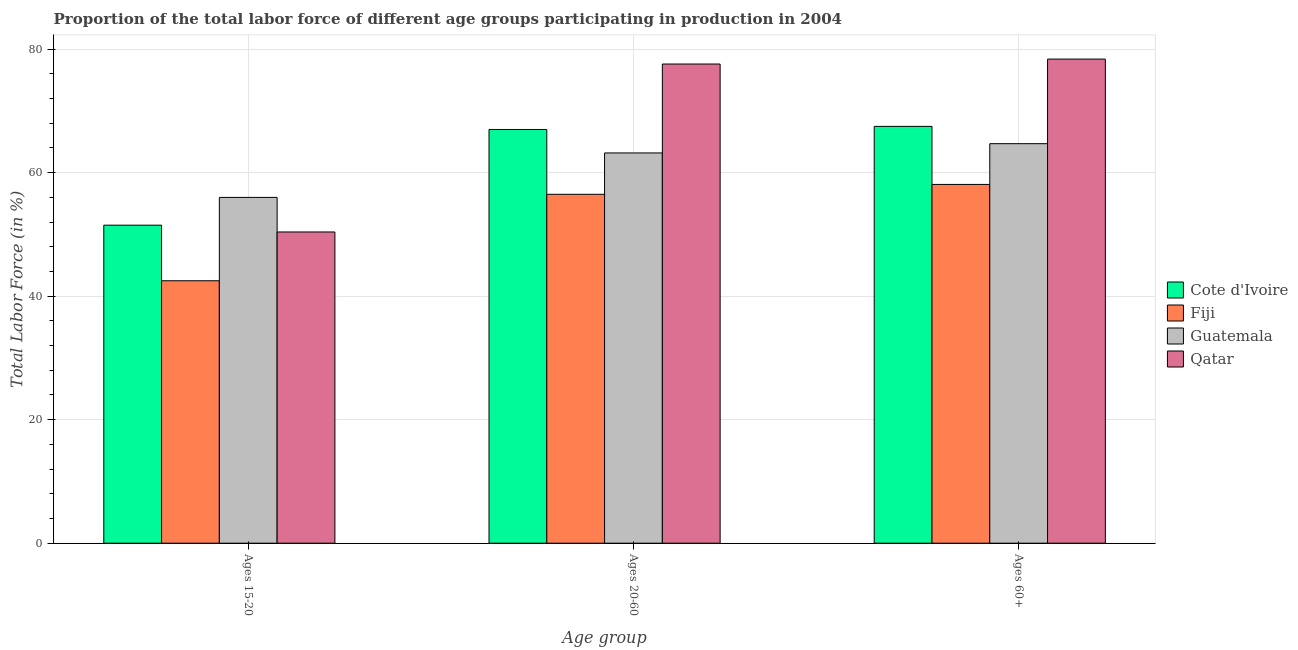How many different coloured bars are there?
Your answer should be compact. 4. How many groups of bars are there?
Give a very brief answer. 3. Are the number of bars per tick equal to the number of legend labels?
Your response must be concise. Yes. Are the number of bars on each tick of the X-axis equal?
Offer a terse response. Yes. What is the label of the 1st group of bars from the left?
Your response must be concise. Ages 15-20. What is the percentage of labor force within the age group 15-20 in Qatar?
Give a very brief answer. 50.4. Across all countries, what is the maximum percentage of labor force within the age group 20-60?
Provide a succinct answer. 77.6. Across all countries, what is the minimum percentage of labor force within the age group 20-60?
Offer a very short reply. 56.5. In which country was the percentage of labor force within the age group 20-60 maximum?
Your answer should be compact. Qatar. In which country was the percentage of labor force above age 60 minimum?
Your response must be concise. Fiji. What is the total percentage of labor force within the age group 20-60 in the graph?
Keep it short and to the point. 264.3. What is the difference between the percentage of labor force within the age group 20-60 in Guatemala and that in Fiji?
Your answer should be compact. 6.7. What is the difference between the percentage of labor force within the age group 20-60 in Guatemala and the percentage of labor force above age 60 in Fiji?
Keep it short and to the point. 5.1. What is the average percentage of labor force within the age group 15-20 per country?
Make the answer very short. 50.1. What is the difference between the percentage of labor force within the age group 15-20 and percentage of labor force within the age group 20-60 in Guatemala?
Offer a terse response. -7.2. In how many countries, is the percentage of labor force within the age group 20-60 greater than 24 %?
Ensure brevity in your answer.  4. What is the ratio of the percentage of labor force above age 60 in Guatemala to that in Qatar?
Provide a succinct answer. 0.83. Is the percentage of labor force within the age group 15-20 in Cote d'Ivoire less than that in Guatemala?
Your response must be concise. Yes. What is the difference between the highest and the second highest percentage of labor force above age 60?
Offer a very short reply. 10.9. What is the difference between the highest and the lowest percentage of labor force within the age group 20-60?
Offer a very short reply. 21.1. In how many countries, is the percentage of labor force above age 60 greater than the average percentage of labor force above age 60 taken over all countries?
Offer a terse response. 2. What does the 4th bar from the left in Ages 15-20 represents?
Your answer should be very brief. Qatar. What does the 2nd bar from the right in Ages 20-60 represents?
Make the answer very short. Guatemala. Is it the case that in every country, the sum of the percentage of labor force within the age group 15-20 and percentage of labor force within the age group 20-60 is greater than the percentage of labor force above age 60?
Give a very brief answer. Yes. How many bars are there?
Make the answer very short. 12. Are all the bars in the graph horizontal?
Ensure brevity in your answer.  No. Does the graph contain grids?
Offer a terse response. Yes. Where does the legend appear in the graph?
Your answer should be compact. Center right. How many legend labels are there?
Keep it short and to the point. 4. What is the title of the graph?
Make the answer very short. Proportion of the total labor force of different age groups participating in production in 2004. What is the label or title of the X-axis?
Offer a terse response. Age group. What is the label or title of the Y-axis?
Provide a short and direct response. Total Labor Force (in %). What is the Total Labor Force (in %) of Cote d'Ivoire in Ages 15-20?
Your response must be concise. 51.5. What is the Total Labor Force (in %) in Fiji in Ages 15-20?
Your response must be concise. 42.5. What is the Total Labor Force (in %) of Qatar in Ages 15-20?
Your answer should be compact. 50.4. What is the Total Labor Force (in %) of Fiji in Ages 20-60?
Your response must be concise. 56.5. What is the Total Labor Force (in %) in Guatemala in Ages 20-60?
Make the answer very short. 63.2. What is the Total Labor Force (in %) in Qatar in Ages 20-60?
Keep it short and to the point. 77.6. What is the Total Labor Force (in %) in Cote d'Ivoire in Ages 60+?
Your answer should be very brief. 67.5. What is the Total Labor Force (in %) of Fiji in Ages 60+?
Give a very brief answer. 58.1. What is the Total Labor Force (in %) in Guatemala in Ages 60+?
Ensure brevity in your answer.  64.7. What is the Total Labor Force (in %) of Qatar in Ages 60+?
Provide a succinct answer. 78.4. Across all Age group, what is the maximum Total Labor Force (in %) in Cote d'Ivoire?
Make the answer very short. 67.5. Across all Age group, what is the maximum Total Labor Force (in %) in Fiji?
Provide a succinct answer. 58.1. Across all Age group, what is the maximum Total Labor Force (in %) of Guatemala?
Your answer should be very brief. 64.7. Across all Age group, what is the maximum Total Labor Force (in %) in Qatar?
Ensure brevity in your answer.  78.4. Across all Age group, what is the minimum Total Labor Force (in %) in Cote d'Ivoire?
Keep it short and to the point. 51.5. Across all Age group, what is the minimum Total Labor Force (in %) of Fiji?
Give a very brief answer. 42.5. Across all Age group, what is the minimum Total Labor Force (in %) of Qatar?
Ensure brevity in your answer.  50.4. What is the total Total Labor Force (in %) in Cote d'Ivoire in the graph?
Provide a short and direct response. 186. What is the total Total Labor Force (in %) of Fiji in the graph?
Make the answer very short. 157.1. What is the total Total Labor Force (in %) in Guatemala in the graph?
Offer a terse response. 183.9. What is the total Total Labor Force (in %) in Qatar in the graph?
Offer a very short reply. 206.4. What is the difference between the Total Labor Force (in %) in Cote d'Ivoire in Ages 15-20 and that in Ages 20-60?
Your answer should be very brief. -15.5. What is the difference between the Total Labor Force (in %) of Qatar in Ages 15-20 and that in Ages 20-60?
Your answer should be very brief. -27.2. What is the difference between the Total Labor Force (in %) in Fiji in Ages 15-20 and that in Ages 60+?
Your response must be concise. -15.6. What is the difference between the Total Labor Force (in %) in Guatemala in Ages 15-20 and that in Ages 60+?
Your response must be concise. -8.7. What is the difference between the Total Labor Force (in %) of Cote d'Ivoire in Ages 20-60 and that in Ages 60+?
Your answer should be compact. -0.5. What is the difference between the Total Labor Force (in %) of Guatemala in Ages 20-60 and that in Ages 60+?
Ensure brevity in your answer.  -1.5. What is the difference between the Total Labor Force (in %) of Cote d'Ivoire in Ages 15-20 and the Total Labor Force (in %) of Guatemala in Ages 20-60?
Make the answer very short. -11.7. What is the difference between the Total Labor Force (in %) of Cote d'Ivoire in Ages 15-20 and the Total Labor Force (in %) of Qatar in Ages 20-60?
Give a very brief answer. -26.1. What is the difference between the Total Labor Force (in %) in Fiji in Ages 15-20 and the Total Labor Force (in %) in Guatemala in Ages 20-60?
Your response must be concise. -20.7. What is the difference between the Total Labor Force (in %) of Fiji in Ages 15-20 and the Total Labor Force (in %) of Qatar in Ages 20-60?
Your answer should be very brief. -35.1. What is the difference between the Total Labor Force (in %) of Guatemala in Ages 15-20 and the Total Labor Force (in %) of Qatar in Ages 20-60?
Provide a succinct answer. -21.6. What is the difference between the Total Labor Force (in %) of Cote d'Ivoire in Ages 15-20 and the Total Labor Force (in %) of Fiji in Ages 60+?
Offer a very short reply. -6.6. What is the difference between the Total Labor Force (in %) of Cote d'Ivoire in Ages 15-20 and the Total Labor Force (in %) of Qatar in Ages 60+?
Ensure brevity in your answer.  -26.9. What is the difference between the Total Labor Force (in %) of Fiji in Ages 15-20 and the Total Labor Force (in %) of Guatemala in Ages 60+?
Make the answer very short. -22.2. What is the difference between the Total Labor Force (in %) of Fiji in Ages 15-20 and the Total Labor Force (in %) of Qatar in Ages 60+?
Make the answer very short. -35.9. What is the difference between the Total Labor Force (in %) of Guatemala in Ages 15-20 and the Total Labor Force (in %) of Qatar in Ages 60+?
Your answer should be compact. -22.4. What is the difference between the Total Labor Force (in %) of Cote d'Ivoire in Ages 20-60 and the Total Labor Force (in %) of Guatemala in Ages 60+?
Ensure brevity in your answer.  2.3. What is the difference between the Total Labor Force (in %) in Fiji in Ages 20-60 and the Total Labor Force (in %) in Guatemala in Ages 60+?
Your response must be concise. -8.2. What is the difference between the Total Labor Force (in %) of Fiji in Ages 20-60 and the Total Labor Force (in %) of Qatar in Ages 60+?
Provide a short and direct response. -21.9. What is the difference between the Total Labor Force (in %) in Guatemala in Ages 20-60 and the Total Labor Force (in %) in Qatar in Ages 60+?
Give a very brief answer. -15.2. What is the average Total Labor Force (in %) in Cote d'Ivoire per Age group?
Your answer should be compact. 62. What is the average Total Labor Force (in %) of Fiji per Age group?
Provide a short and direct response. 52.37. What is the average Total Labor Force (in %) in Guatemala per Age group?
Give a very brief answer. 61.3. What is the average Total Labor Force (in %) of Qatar per Age group?
Give a very brief answer. 68.8. What is the difference between the Total Labor Force (in %) in Cote d'Ivoire and Total Labor Force (in %) in Fiji in Ages 15-20?
Provide a succinct answer. 9. What is the difference between the Total Labor Force (in %) in Cote d'Ivoire and Total Labor Force (in %) in Qatar in Ages 15-20?
Give a very brief answer. 1.1. What is the difference between the Total Labor Force (in %) of Fiji and Total Labor Force (in %) of Guatemala in Ages 15-20?
Offer a terse response. -13.5. What is the difference between the Total Labor Force (in %) of Fiji and Total Labor Force (in %) of Qatar in Ages 15-20?
Your response must be concise. -7.9. What is the difference between the Total Labor Force (in %) of Guatemala and Total Labor Force (in %) of Qatar in Ages 15-20?
Offer a very short reply. 5.6. What is the difference between the Total Labor Force (in %) in Cote d'Ivoire and Total Labor Force (in %) in Guatemala in Ages 20-60?
Your answer should be very brief. 3.8. What is the difference between the Total Labor Force (in %) in Fiji and Total Labor Force (in %) in Guatemala in Ages 20-60?
Offer a terse response. -6.7. What is the difference between the Total Labor Force (in %) of Fiji and Total Labor Force (in %) of Qatar in Ages 20-60?
Offer a terse response. -21.1. What is the difference between the Total Labor Force (in %) in Guatemala and Total Labor Force (in %) in Qatar in Ages 20-60?
Offer a terse response. -14.4. What is the difference between the Total Labor Force (in %) of Cote d'Ivoire and Total Labor Force (in %) of Fiji in Ages 60+?
Provide a succinct answer. 9.4. What is the difference between the Total Labor Force (in %) in Cote d'Ivoire and Total Labor Force (in %) in Guatemala in Ages 60+?
Provide a succinct answer. 2.8. What is the difference between the Total Labor Force (in %) in Cote d'Ivoire and Total Labor Force (in %) in Qatar in Ages 60+?
Your answer should be very brief. -10.9. What is the difference between the Total Labor Force (in %) in Fiji and Total Labor Force (in %) in Guatemala in Ages 60+?
Keep it short and to the point. -6.6. What is the difference between the Total Labor Force (in %) in Fiji and Total Labor Force (in %) in Qatar in Ages 60+?
Your answer should be very brief. -20.3. What is the difference between the Total Labor Force (in %) of Guatemala and Total Labor Force (in %) of Qatar in Ages 60+?
Offer a very short reply. -13.7. What is the ratio of the Total Labor Force (in %) of Cote d'Ivoire in Ages 15-20 to that in Ages 20-60?
Ensure brevity in your answer.  0.77. What is the ratio of the Total Labor Force (in %) of Fiji in Ages 15-20 to that in Ages 20-60?
Your answer should be compact. 0.75. What is the ratio of the Total Labor Force (in %) of Guatemala in Ages 15-20 to that in Ages 20-60?
Offer a terse response. 0.89. What is the ratio of the Total Labor Force (in %) of Qatar in Ages 15-20 to that in Ages 20-60?
Your answer should be compact. 0.65. What is the ratio of the Total Labor Force (in %) in Cote d'Ivoire in Ages 15-20 to that in Ages 60+?
Provide a succinct answer. 0.76. What is the ratio of the Total Labor Force (in %) of Fiji in Ages 15-20 to that in Ages 60+?
Ensure brevity in your answer.  0.73. What is the ratio of the Total Labor Force (in %) of Guatemala in Ages 15-20 to that in Ages 60+?
Your answer should be compact. 0.87. What is the ratio of the Total Labor Force (in %) of Qatar in Ages 15-20 to that in Ages 60+?
Provide a short and direct response. 0.64. What is the ratio of the Total Labor Force (in %) of Fiji in Ages 20-60 to that in Ages 60+?
Your answer should be very brief. 0.97. What is the ratio of the Total Labor Force (in %) of Guatemala in Ages 20-60 to that in Ages 60+?
Provide a short and direct response. 0.98. What is the difference between the highest and the second highest Total Labor Force (in %) of Cote d'Ivoire?
Give a very brief answer. 0.5. What is the difference between the highest and the lowest Total Labor Force (in %) in Cote d'Ivoire?
Your response must be concise. 16. 